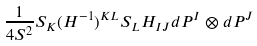<formula> <loc_0><loc_0><loc_500><loc_500>\frac { 1 } { 4 S ^ { 2 } } S _ { K } ( H ^ { - 1 } ) ^ { K L } S _ { L } H _ { I J } d P ^ { I } \otimes d P ^ { J }</formula> 